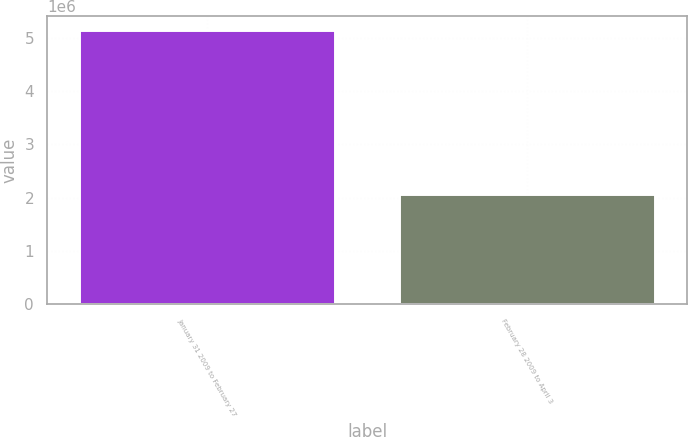Convert chart to OTSL. <chart><loc_0><loc_0><loc_500><loc_500><bar_chart><fcel>January 31 2009 to February 27<fcel>February 28 2009 to April 3<nl><fcel>5.1492e+06<fcel>2.0779e+06<nl></chart> 